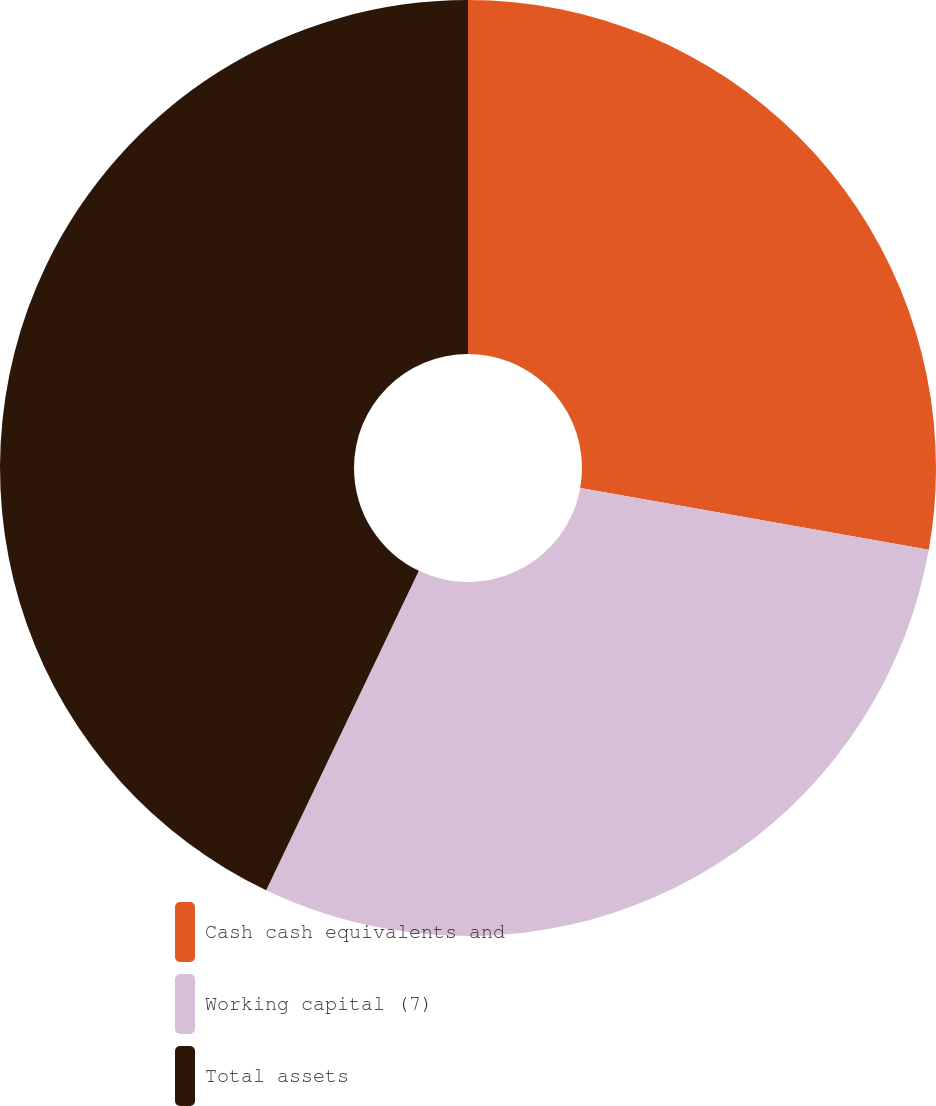Convert chart. <chart><loc_0><loc_0><loc_500><loc_500><pie_chart><fcel>Cash cash equivalents and<fcel>Working capital (7)<fcel>Total assets<nl><fcel>27.79%<fcel>29.3%<fcel>42.9%<nl></chart> 